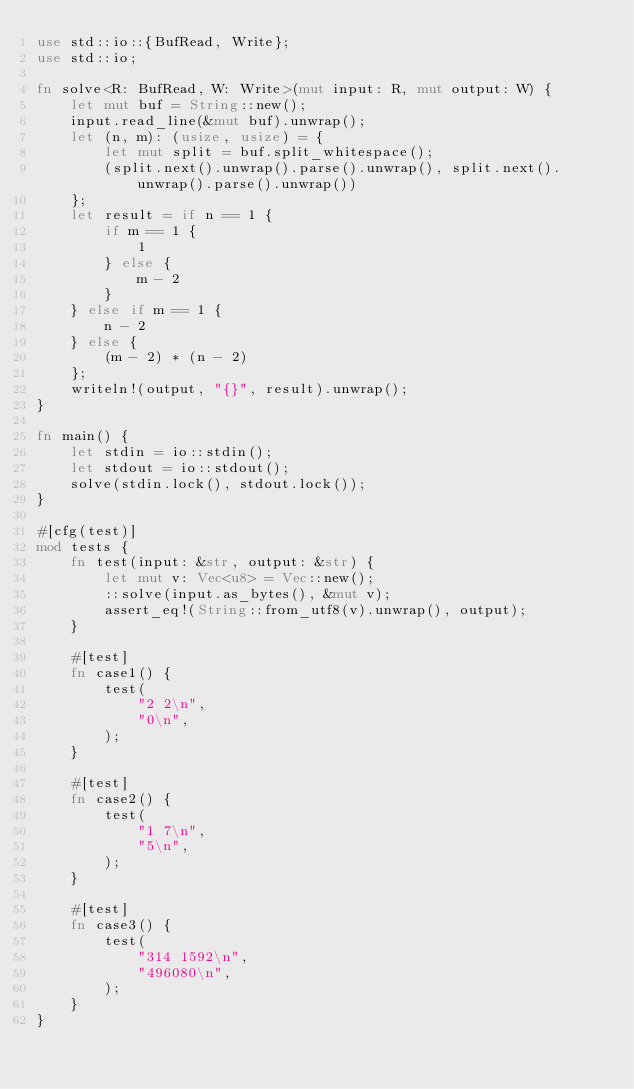<code> <loc_0><loc_0><loc_500><loc_500><_Rust_>use std::io::{BufRead, Write};
use std::io;

fn solve<R: BufRead, W: Write>(mut input: R, mut output: W) {
    let mut buf = String::new();
    input.read_line(&mut buf).unwrap();
    let (n, m): (usize, usize) = {
        let mut split = buf.split_whitespace();
        (split.next().unwrap().parse().unwrap(), split.next().unwrap().parse().unwrap())
    };
    let result = if n == 1 {
        if m == 1 {
            1
        } else {
            m - 2
        }
    } else if m == 1 {
        n - 2
    } else {
        (m - 2) * (n - 2)
    };
    writeln!(output, "{}", result).unwrap();
}

fn main() {
    let stdin = io::stdin();
    let stdout = io::stdout();
    solve(stdin.lock(), stdout.lock());
}

#[cfg(test)]
mod tests {
    fn test(input: &str, output: &str) {
        let mut v: Vec<u8> = Vec::new();
        ::solve(input.as_bytes(), &mut v);
        assert_eq!(String::from_utf8(v).unwrap(), output);
    }

    #[test]
    fn case1() {
        test(
            "2 2\n",
            "0\n",
        );
    }

    #[test]
    fn case2() {
        test(
            "1 7\n",
            "5\n",
        );
    }

    #[test]
    fn case3() {
        test(
            "314 1592\n",
            "496080\n",
        );
    }
}</code> 